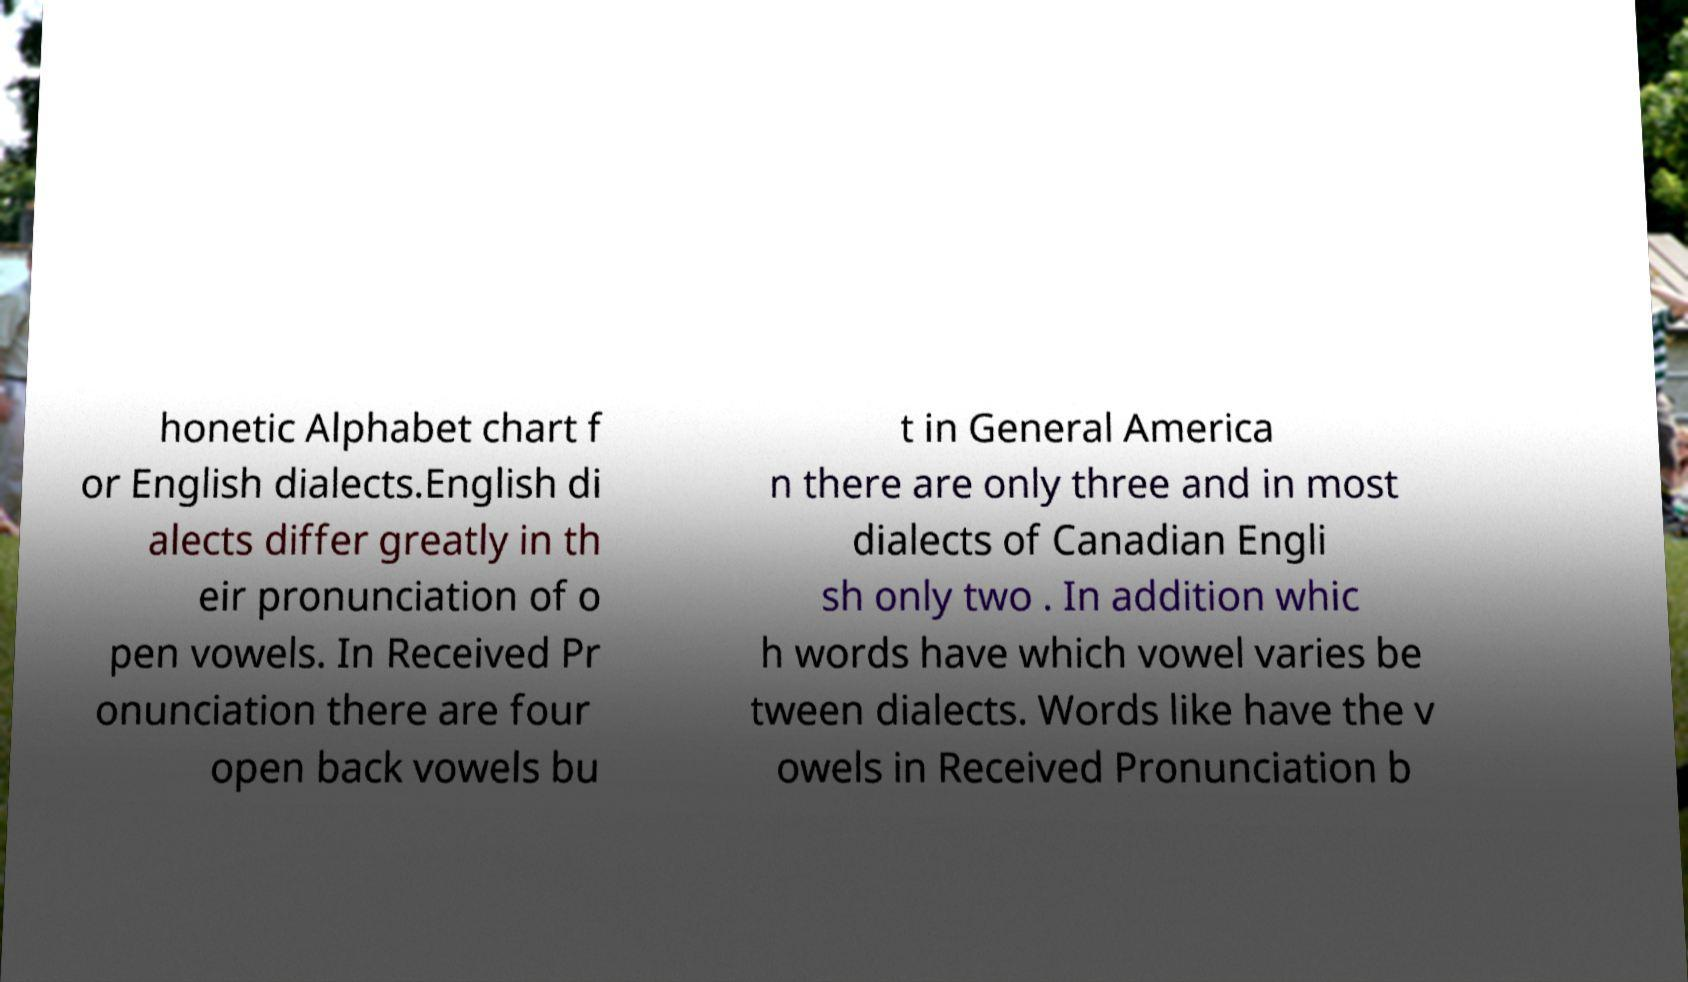Could you extract and type out the text from this image? honetic Alphabet chart f or English dialects.English di alects differ greatly in th eir pronunciation of o pen vowels. In Received Pr onunciation there are four open back vowels bu t in General America n there are only three and in most dialects of Canadian Engli sh only two . In addition whic h words have which vowel varies be tween dialects. Words like have the v owels in Received Pronunciation b 